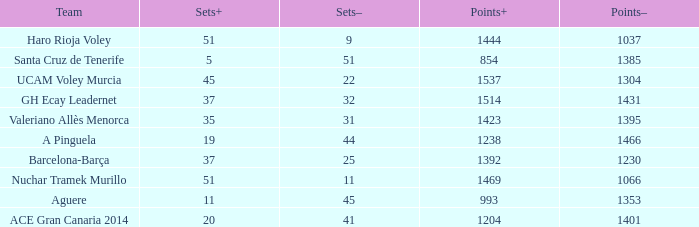Who is the team who had a Sets+ number smaller than 20, a Sets- number of 45, and a Points+ number smaller than 1238? Aguere. 